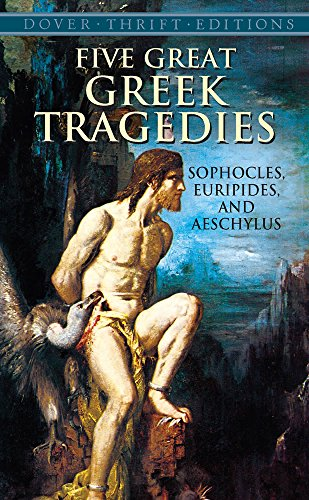How has Ancient Greek tragedy influenced modern literature? Ancient Greek tragedies, with their complex characters and themes of fate, morality, and human suffering, have laid foundational concepts for dramatic narratives, influencing playwriting and literature across cultures and epochs. 